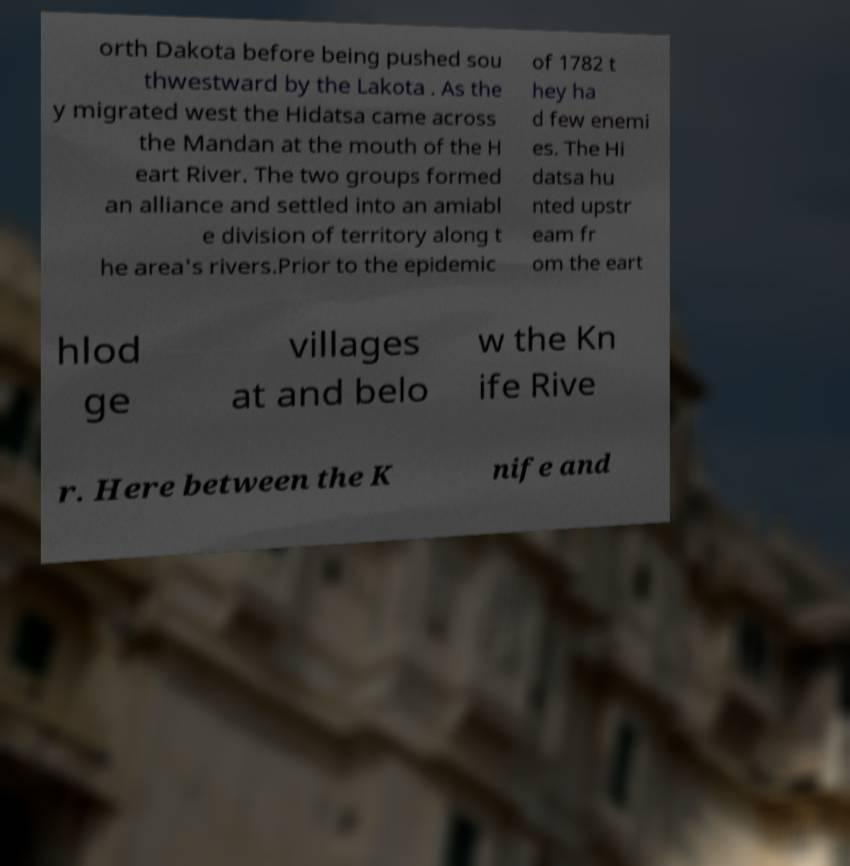Could you extract and type out the text from this image? orth Dakota before being pushed sou thwestward by the Lakota . As the y migrated west the Hidatsa came across the Mandan at the mouth of the H eart River. The two groups formed an alliance and settled into an amiabl e division of territory along t he area's rivers.Prior to the epidemic of 1782 t hey ha d few enemi es. The Hi datsa hu nted upstr eam fr om the eart hlod ge villages at and belo w the Kn ife Rive r. Here between the K nife and 